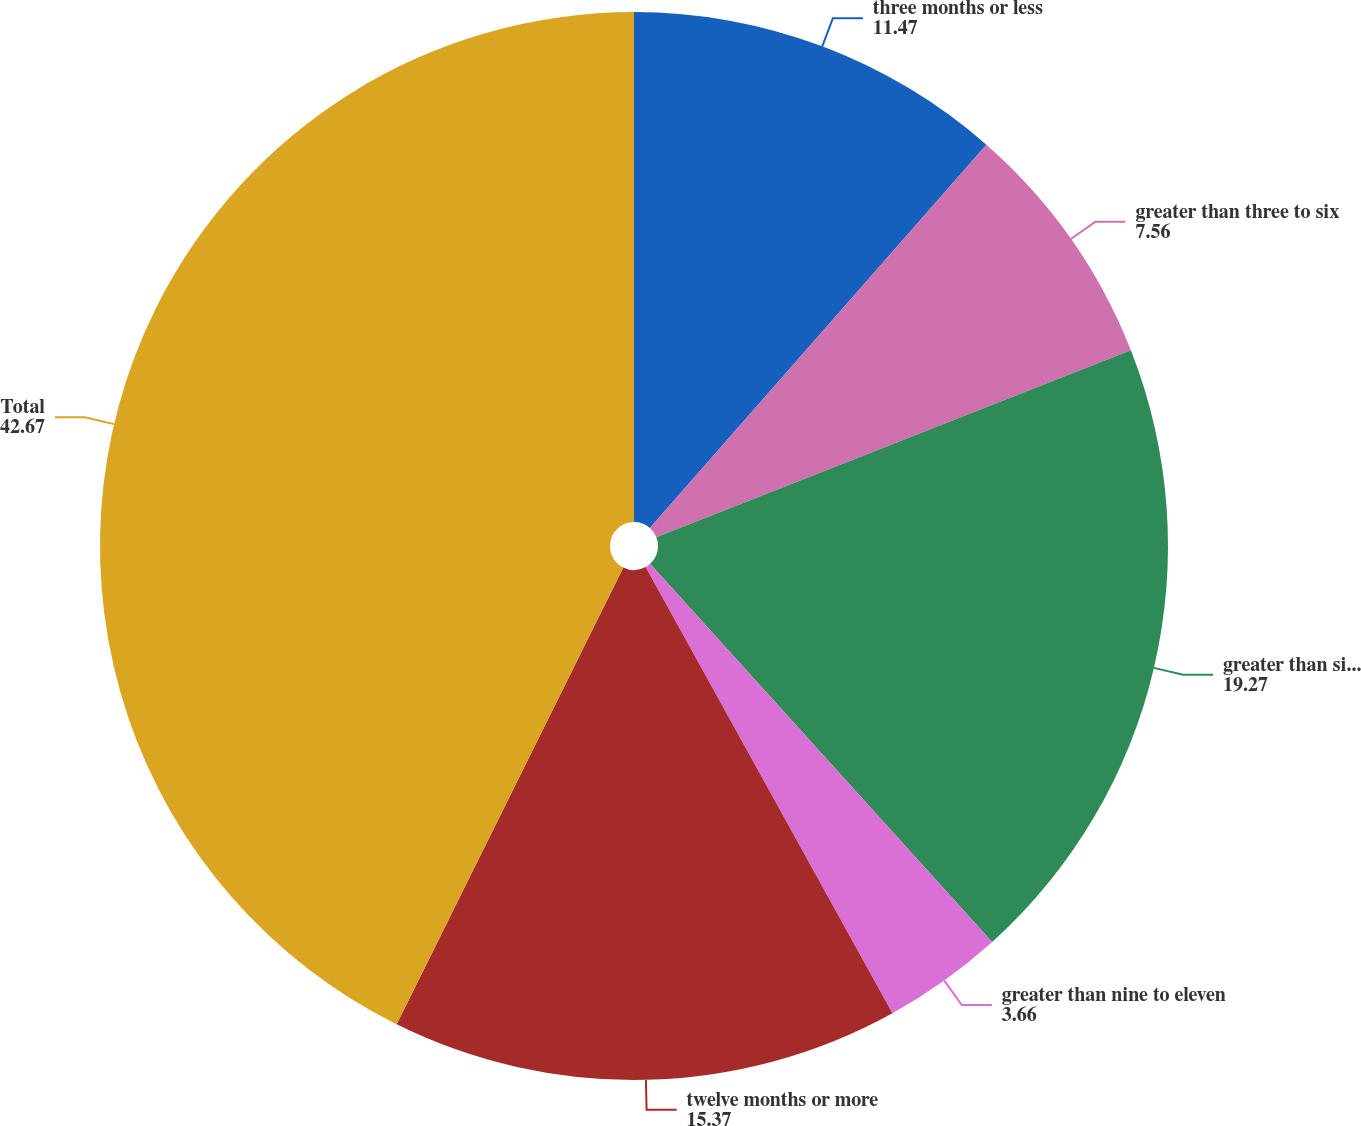Convert chart to OTSL. <chart><loc_0><loc_0><loc_500><loc_500><pie_chart><fcel>three months or less<fcel>greater than three to six<fcel>greater than six to nine<fcel>greater than nine to eleven<fcel>twelve months or more<fcel>Total<nl><fcel>11.47%<fcel>7.56%<fcel>19.27%<fcel>3.66%<fcel>15.37%<fcel>42.67%<nl></chart> 